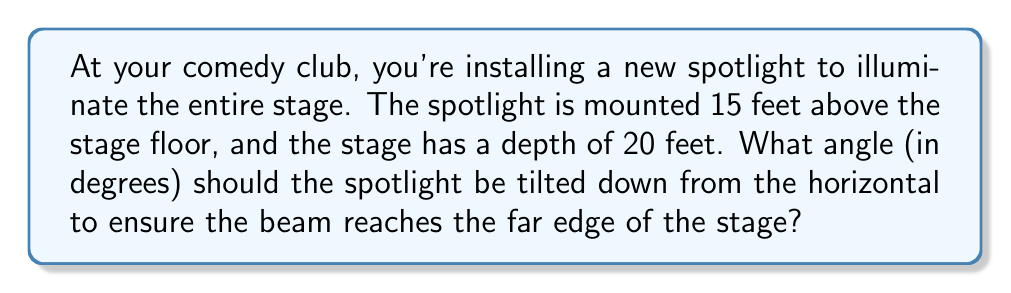Can you answer this question? Let's approach this step-by-step using trigonometry:

1) First, we need to visualize the problem. We have a right triangle where:
   - The vertical height of the spotlight is 15 feet
   - The horizontal distance to the far edge of the stage is 20 feet
   - The angle we're looking for is the one between the horizontal and the spotlight beam

2) We can represent this situation with the following diagram:

[asy]
import geometry;

pair A = (0,0), B = (20,0), C = (0,15);
draw(A--B--C--A);
draw(C--(20,15),dashed);
label("15 ft", (0,7.5), W);
label("20 ft", (10,0), S);
label("$\theta$", (1,14), NW);
dot("Spotlight", C, NW);
dot("Stage edge", B, SE);
[/asy]

3) In this right triangle, we need to find the angle $\theta$.

4) We can use the arctangent function to find this angle. The tangent of an angle in a right triangle is the opposite side divided by the adjacent side.

5) In our case:
   $\tan(\theta) = \frac{\text{opposite}}{\text{adjacent}} = \frac{15}{20} = \frac{3}{4} = 0.75$

6) To find $\theta$, we take the arctangent (or inverse tangent) of this ratio:
   $\theta = \arctan(0.75)$

7) Using a calculator or computer, we can determine that:
   $\theta \approx 36.87°$

This is the angle that the spotlight should be tilted down from the horizontal.
Answer: $36.87°$ 